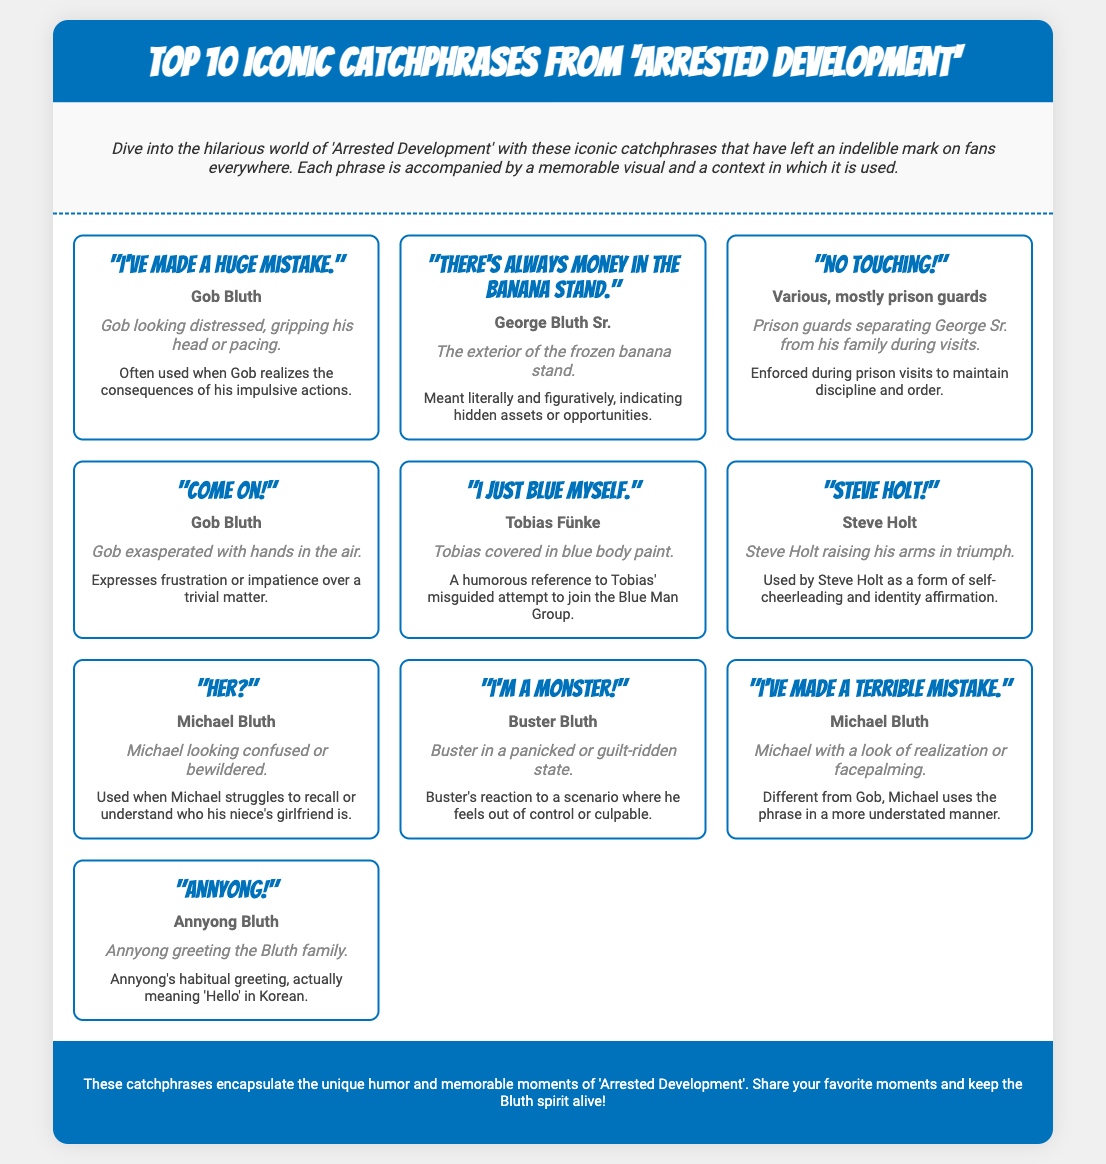what is the first catchphrase listed? The first catchphrase is the one displayed at the top of the catchphrase cards grid.
Answer: "I've made a huge mistake." who says "There's always money in the banana stand"? This phrase is attributed to one of the main characters in the series.
Answer: George Bluth Sr how many phrases are displayed in total? The total number of catchphrases can be counted from the number of cards shown in the infographic.
Answer: 10 what phrase is associated with Gob Bluth expressing frustration? Gob Bluth has a specific catchphrase that shows his exasperation.
Answer: "Come on!" who is depicted looking confused in the document? The character who is shown bewildered is specifically mentioned with the catchphrase.
Answer: Michael Bluth which catchphrase is linked to Tobias Fünke's attempt to fit in? Tobias's humorous reference to his situation is identified by this catchphrase.
Answer: "I just blue myself." what is Annyong using as his greeting? Annyong has a distinct phrase he frequently uses when addressing others.
Answer: "Annyong!" which character looks panicked and says "I'm a monster!"? The character's name is directly mentioned alongside the particular catchphrase.
Answer: Buster Bluth which catchphrase does Michael Bluth use after realizing something? This is a common phrase he employs when he acknowledges a mistake.
Answer: "I've made a terrible mistake." 